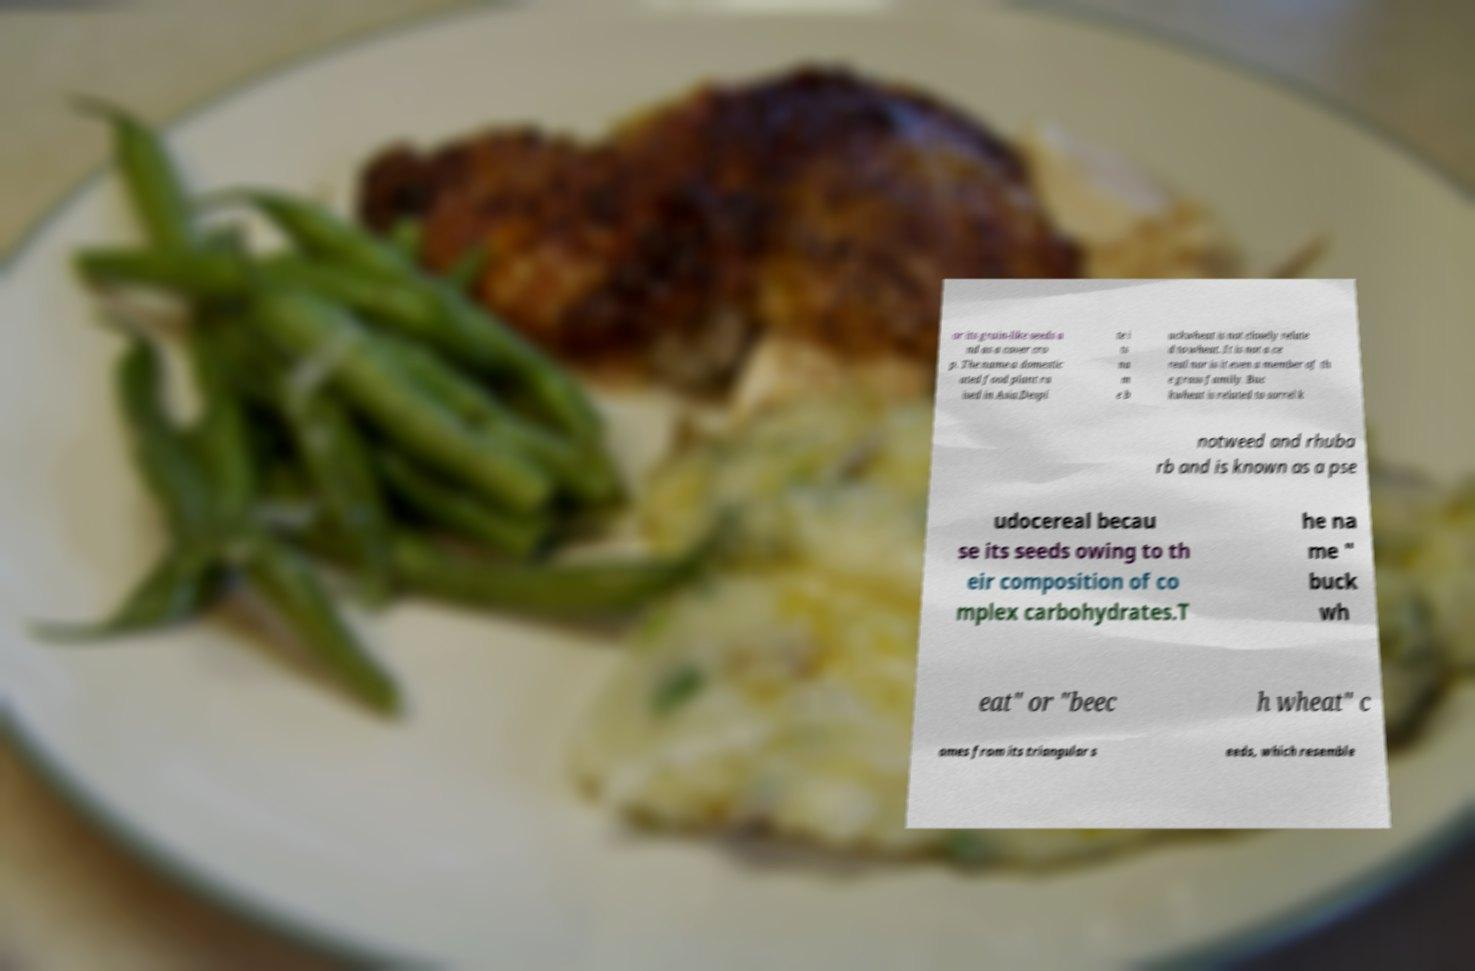Please read and relay the text visible in this image. What does it say? or its grain-like seeds a nd as a cover cro p. The name a domestic ated food plant ra ised in Asia.Despi te i ts na m e b uckwheat is not closely relate d to wheat. It is not a ce real nor is it even a member of th e grass family. Buc kwheat is related to sorrel k notweed and rhuba rb and is known as a pse udocereal becau se its seeds owing to th eir composition of co mplex carbohydrates.T he na me " buck wh eat" or "beec h wheat" c omes from its triangular s eeds, which resemble 